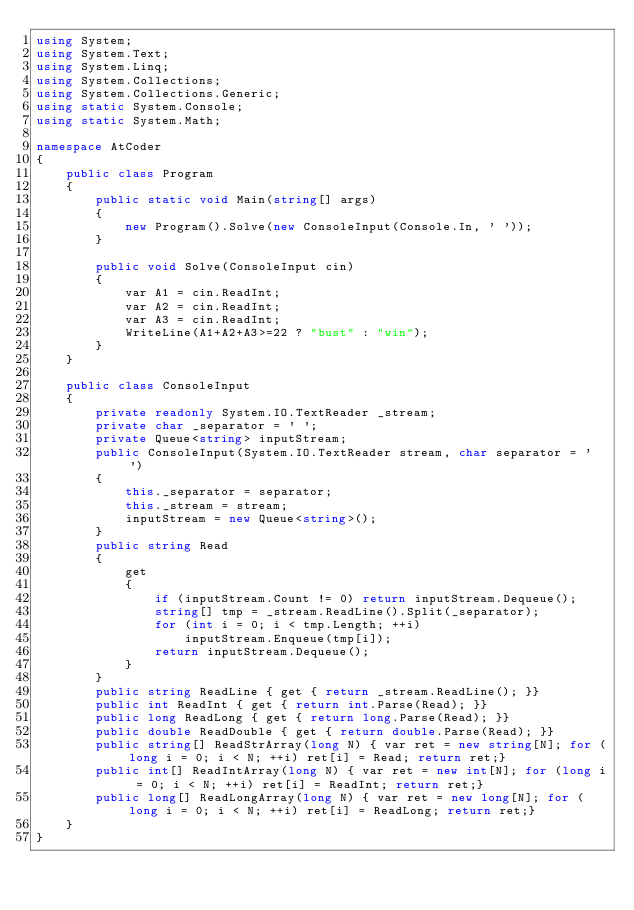<code> <loc_0><loc_0><loc_500><loc_500><_C#_>using System;
using System.Text;
using System.Linq;
using System.Collections;
using System.Collections.Generic;
using static System.Console;
using static System.Math;

namespace AtCoder
{
    public class Program
    {
        public static void Main(string[] args)
        {
            new Program().Solve(new ConsoleInput(Console.In, ' '));
        }

        public void Solve(ConsoleInput cin)
        {
            var A1 = cin.ReadInt;
            var A2 = cin.ReadInt;
            var A3 = cin.ReadInt;
            WriteLine(A1+A2+A3>=22 ? "bust" : "win");
        }
    }

    public class ConsoleInput
    {
        private readonly System.IO.TextReader _stream;
        private char _separator = ' ';
        private Queue<string> inputStream;
        public ConsoleInput(System.IO.TextReader stream, char separator = ' ')
        {
            this._separator = separator;
            this._stream = stream;
            inputStream = new Queue<string>();
        }
        public string Read
        {
            get
            {
                if (inputStream.Count != 0) return inputStream.Dequeue();
                string[] tmp = _stream.ReadLine().Split(_separator);
                for (int i = 0; i < tmp.Length; ++i)
                    inputStream.Enqueue(tmp[i]);
                return inputStream.Dequeue();
            }
        }
        public string ReadLine { get { return _stream.ReadLine(); }}
        public int ReadInt { get { return int.Parse(Read); }}
        public long ReadLong { get { return long.Parse(Read); }}
        public double ReadDouble { get { return double.Parse(Read); }}
        public string[] ReadStrArray(long N) { var ret = new string[N]; for (long i = 0; i < N; ++i) ret[i] = Read; return ret;}
        public int[] ReadIntArray(long N) { var ret = new int[N]; for (long i = 0; i < N; ++i) ret[i] = ReadInt; return ret;}
        public long[] ReadLongArray(long N) { var ret = new long[N]; for (long i = 0; i < N; ++i) ret[i] = ReadLong; return ret;}
    }
}
</code> 